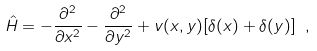Convert formula to latex. <formula><loc_0><loc_0><loc_500><loc_500>\hat { H } = - \frac { \partial ^ { 2 } } { \partial x ^ { 2 } } - \frac { \partial ^ { 2 } } { \partial y ^ { 2 } } + v ( x , y ) [ \delta ( x ) + \delta ( y ) ] \ ,</formula> 